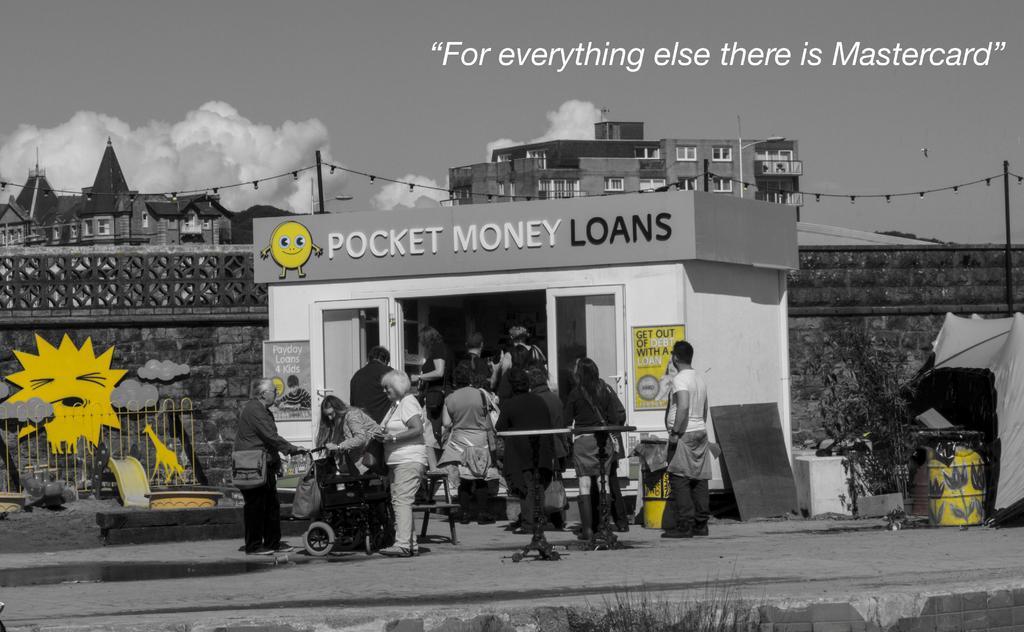Please provide a concise description of this image. This is a black and white edited image, in this image there are people doing different activities, in the background there is a railing, beside that there is a shop, behind the shop there is a wall, behind the wall there are buildings and the sky and there are few yellow colored items, on the top right there is text. 